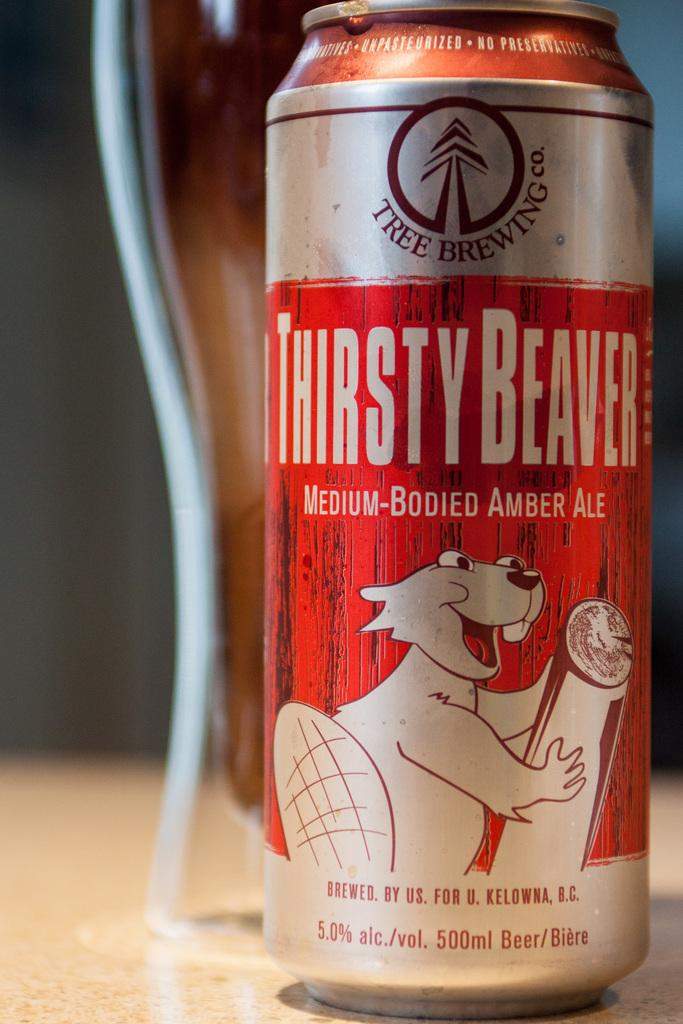<image>
Give a short and clear explanation of the subsequent image. A can of Thirsty Beaver Amber Ale sits on a counter. 